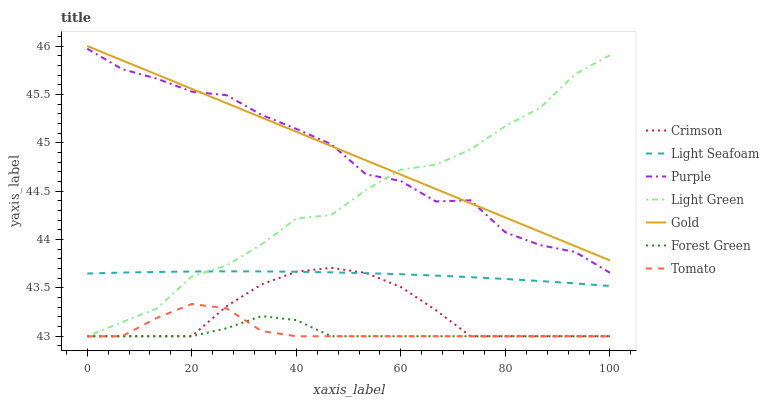Does Forest Green have the minimum area under the curve?
Answer yes or no. Yes. Does Gold have the maximum area under the curve?
Answer yes or no. Yes. Does Purple have the minimum area under the curve?
Answer yes or no. No. Does Purple have the maximum area under the curve?
Answer yes or no. No. Is Gold the smoothest?
Answer yes or no. Yes. Is Purple the roughest?
Answer yes or no. Yes. Is Purple the smoothest?
Answer yes or no. No. Is Gold the roughest?
Answer yes or no. No. Does Tomato have the lowest value?
Answer yes or no. Yes. Does Purple have the lowest value?
Answer yes or no. No. Does Gold have the highest value?
Answer yes or no. Yes. Does Purple have the highest value?
Answer yes or no. No. Is Forest Green less than Purple?
Answer yes or no. Yes. Is Purple greater than Tomato?
Answer yes or no. Yes. Does Tomato intersect Forest Green?
Answer yes or no. Yes. Is Tomato less than Forest Green?
Answer yes or no. No. Is Tomato greater than Forest Green?
Answer yes or no. No. Does Forest Green intersect Purple?
Answer yes or no. No. 